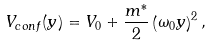<formula> <loc_0><loc_0><loc_500><loc_500>V _ { c o n f } ( y ) = V _ { 0 } + \frac { m ^ { \ast } } { 2 } \left ( \omega _ { 0 } y \right ) ^ { 2 } ,</formula> 